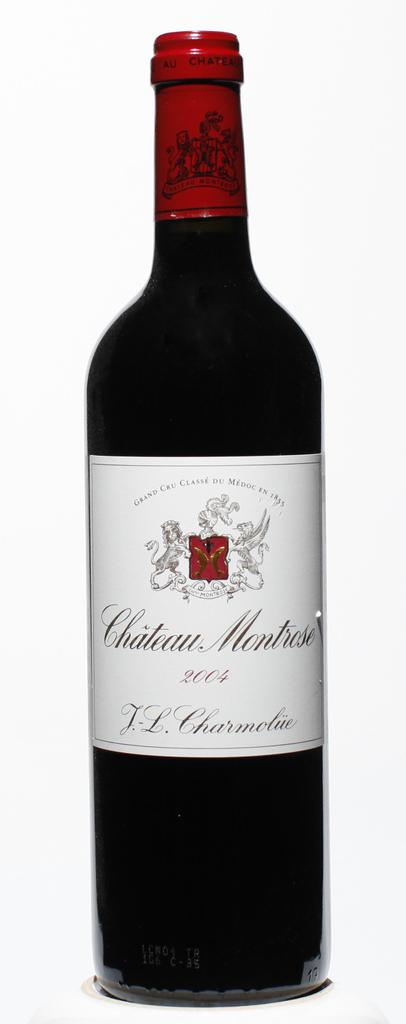What wine is that?
Keep it short and to the point. Chateau montrose. What year is on this wine?
Provide a succinct answer. 2004. 